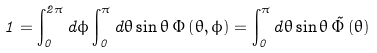<formula> <loc_0><loc_0><loc_500><loc_500>1 = \int _ { 0 } ^ { 2 \pi } d \phi \int _ { 0 } ^ { \pi } d \theta \sin \theta \, \Phi \left ( \theta , \phi \right ) = \int _ { 0 } ^ { \pi } d \theta \sin \theta \, \tilde { \Phi } \left ( \theta \right )</formula> 